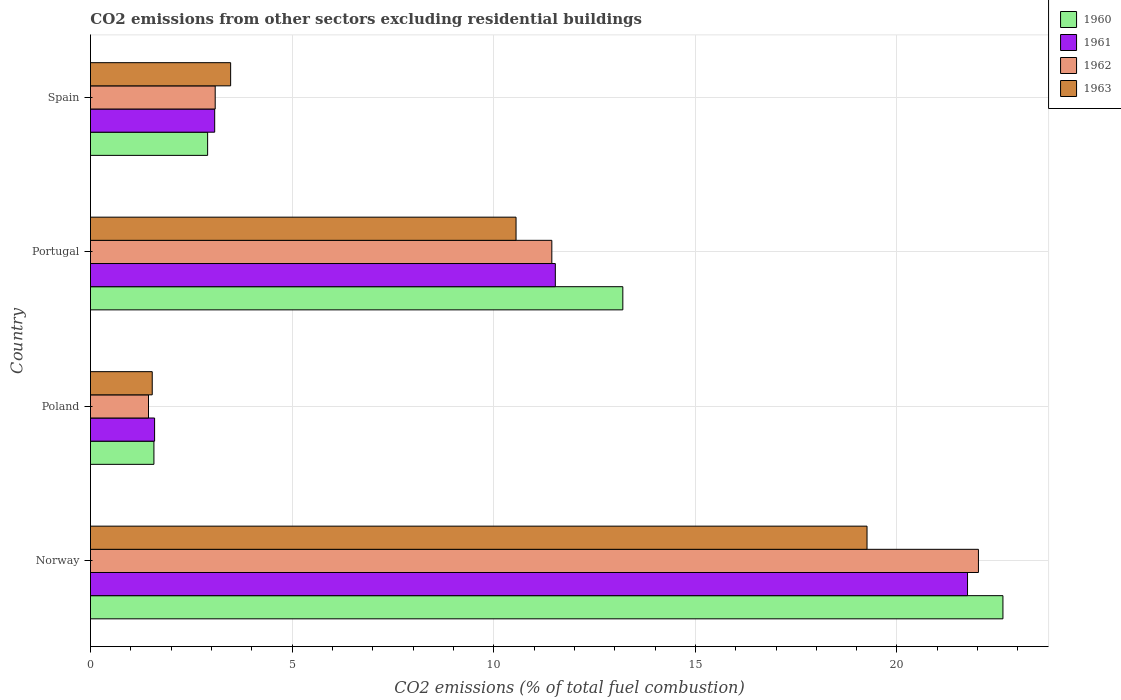Are the number of bars on each tick of the Y-axis equal?
Ensure brevity in your answer.  Yes. How many bars are there on the 4th tick from the bottom?
Ensure brevity in your answer.  4. What is the label of the 1st group of bars from the top?
Ensure brevity in your answer.  Spain. What is the total CO2 emitted in 1963 in Portugal?
Offer a very short reply. 10.55. Across all countries, what is the maximum total CO2 emitted in 1960?
Provide a succinct answer. 22.63. Across all countries, what is the minimum total CO2 emitted in 1962?
Make the answer very short. 1.44. What is the total total CO2 emitted in 1962 in the graph?
Offer a terse response. 37.99. What is the difference between the total CO2 emitted in 1962 in Norway and that in Spain?
Offer a very short reply. 18.93. What is the difference between the total CO2 emitted in 1960 in Poland and the total CO2 emitted in 1963 in Norway?
Keep it short and to the point. -17.68. What is the average total CO2 emitted in 1963 per country?
Offer a very short reply. 8.7. What is the difference between the total CO2 emitted in 1960 and total CO2 emitted in 1962 in Poland?
Offer a very short reply. 0.13. What is the ratio of the total CO2 emitted in 1963 in Norway to that in Portugal?
Your answer should be very brief. 1.82. Is the difference between the total CO2 emitted in 1960 in Norway and Portugal greater than the difference between the total CO2 emitted in 1962 in Norway and Portugal?
Your response must be concise. No. What is the difference between the highest and the second highest total CO2 emitted in 1960?
Keep it short and to the point. 9.43. What is the difference between the highest and the lowest total CO2 emitted in 1960?
Provide a short and direct response. 21.05. Is the sum of the total CO2 emitted in 1960 in Portugal and Spain greater than the maximum total CO2 emitted in 1962 across all countries?
Your response must be concise. No. What does the 4th bar from the top in Portugal represents?
Provide a succinct answer. 1960. Is it the case that in every country, the sum of the total CO2 emitted in 1962 and total CO2 emitted in 1960 is greater than the total CO2 emitted in 1961?
Ensure brevity in your answer.  Yes. What is the difference between two consecutive major ticks on the X-axis?
Your answer should be compact. 5. Are the values on the major ticks of X-axis written in scientific E-notation?
Give a very brief answer. No. Where does the legend appear in the graph?
Provide a short and direct response. Top right. How many legend labels are there?
Make the answer very short. 4. How are the legend labels stacked?
Make the answer very short. Vertical. What is the title of the graph?
Make the answer very short. CO2 emissions from other sectors excluding residential buildings. What is the label or title of the X-axis?
Offer a very short reply. CO2 emissions (% of total fuel combustion). What is the CO2 emissions (% of total fuel combustion) of 1960 in Norway?
Make the answer very short. 22.63. What is the CO2 emissions (% of total fuel combustion) of 1961 in Norway?
Make the answer very short. 21.75. What is the CO2 emissions (% of total fuel combustion) in 1962 in Norway?
Offer a very short reply. 22.02. What is the CO2 emissions (% of total fuel combustion) of 1963 in Norway?
Your answer should be compact. 19.26. What is the CO2 emissions (% of total fuel combustion) of 1960 in Poland?
Make the answer very short. 1.57. What is the CO2 emissions (% of total fuel combustion) in 1961 in Poland?
Your response must be concise. 1.59. What is the CO2 emissions (% of total fuel combustion) of 1962 in Poland?
Your answer should be very brief. 1.44. What is the CO2 emissions (% of total fuel combustion) of 1963 in Poland?
Your answer should be very brief. 1.53. What is the CO2 emissions (% of total fuel combustion) in 1960 in Portugal?
Make the answer very short. 13.2. What is the CO2 emissions (% of total fuel combustion) in 1961 in Portugal?
Your answer should be very brief. 11.53. What is the CO2 emissions (% of total fuel combustion) of 1962 in Portugal?
Ensure brevity in your answer.  11.44. What is the CO2 emissions (% of total fuel combustion) of 1963 in Portugal?
Provide a short and direct response. 10.55. What is the CO2 emissions (% of total fuel combustion) in 1960 in Spain?
Provide a succinct answer. 2.91. What is the CO2 emissions (% of total fuel combustion) of 1961 in Spain?
Your response must be concise. 3.08. What is the CO2 emissions (% of total fuel combustion) in 1962 in Spain?
Keep it short and to the point. 3.09. What is the CO2 emissions (% of total fuel combustion) of 1963 in Spain?
Keep it short and to the point. 3.48. Across all countries, what is the maximum CO2 emissions (% of total fuel combustion) in 1960?
Your answer should be very brief. 22.63. Across all countries, what is the maximum CO2 emissions (% of total fuel combustion) of 1961?
Make the answer very short. 21.75. Across all countries, what is the maximum CO2 emissions (% of total fuel combustion) of 1962?
Your response must be concise. 22.02. Across all countries, what is the maximum CO2 emissions (% of total fuel combustion) of 1963?
Make the answer very short. 19.26. Across all countries, what is the minimum CO2 emissions (% of total fuel combustion) in 1960?
Provide a succinct answer. 1.57. Across all countries, what is the minimum CO2 emissions (% of total fuel combustion) in 1961?
Your response must be concise. 1.59. Across all countries, what is the minimum CO2 emissions (% of total fuel combustion) in 1962?
Your answer should be compact. 1.44. Across all countries, what is the minimum CO2 emissions (% of total fuel combustion) of 1963?
Offer a terse response. 1.53. What is the total CO2 emissions (% of total fuel combustion) of 1960 in the graph?
Your answer should be compact. 40.31. What is the total CO2 emissions (% of total fuel combustion) in 1961 in the graph?
Ensure brevity in your answer.  37.95. What is the total CO2 emissions (% of total fuel combustion) of 1962 in the graph?
Ensure brevity in your answer.  37.99. What is the total CO2 emissions (% of total fuel combustion) in 1963 in the graph?
Offer a very short reply. 34.82. What is the difference between the CO2 emissions (% of total fuel combustion) in 1960 in Norway and that in Poland?
Offer a very short reply. 21.05. What is the difference between the CO2 emissions (% of total fuel combustion) of 1961 in Norway and that in Poland?
Your response must be concise. 20.16. What is the difference between the CO2 emissions (% of total fuel combustion) in 1962 in Norway and that in Poland?
Provide a short and direct response. 20.58. What is the difference between the CO2 emissions (% of total fuel combustion) in 1963 in Norway and that in Poland?
Ensure brevity in your answer.  17.73. What is the difference between the CO2 emissions (% of total fuel combustion) in 1960 in Norway and that in Portugal?
Provide a succinct answer. 9.43. What is the difference between the CO2 emissions (% of total fuel combustion) of 1961 in Norway and that in Portugal?
Provide a succinct answer. 10.22. What is the difference between the CO2 emissions (% of total fuel combustion) of 1962 in Norway and that in Portugal?
Give a very brief answer. 10.58. What is the difference between the CO2 emissions (% of total fuel combustion) of 1963 in Norway and that in Portugal?
Make the answer very short. 8.7. What is the difference between the CO2 emissions (% of total fuel combustion) of 1960 in Norway and that in Spain?
Your answer should be compact. 19.72. What is the difference between the CO2 emissions (% of total fuel combustion) of 1961 in Norway and that in Spain?
Offer a terse response. 18.67. What is the difference between the CO2 emissions (% of total fuel combustion) in 1962 in Norway and that in Spain?
Give a very brief answer. 18.93. What is the difference between the CO2 emissions (% of total fuel combustion) in 1963 in Norway and that in Spain?
Provide a short and direct response. 15.78. What is the difference between the CO2 emissions (% of total fuel combustion) in 1960 in Poland and that in Portugal?
Provide a short and direct response. -11.63. What is the difference between the CO2 emissions (% of total fuel combustion) in 1961 in Poland and that in Portugal?
Offer a terse response. -9.94. What is the difference between the CO2 emissions (% of total fuel combustion) in 1962 in Poland and that in Portugal?
Make the answer very short. -10. What is the difference between the CO2 emissions (% of total fuel combustion) of 1963 in Poland and that in Portugal?
Your response must be concise. -9.02. What is the difference between the CO2 emissions (% of total fuel combustion) of 1960 in Poland and that in Spain?
Provide a succinct answer. -1.33. What is the difference between the CO2 emissions (% of total fuel combustion) in 1961 in Poland and that in Spain?
Give a very brief answer. -1.49. What is the difference between the CO2 emissions (% of total fuel combustion) in 1962 in Poland and that in Spain?
Your answer should be compact. -1.65. What is the difference between the CO2 emissions (% of total fuel combustion) in 1963 in Poland and that in Spain?
Ensure brevity in your answer.  -1.94. What is the difference between the CO2 emissions (% of total fuel combustion) of 1960 in Portugal and that in Spain?
Keep it short and to the point. 10.3. What is the difference between the CO2 emissions (% of total fuel combustion) in 1961 in Portugal and that in Spain?
Make the answer very short. 8.45. What is the difference between the CO2 emissions (% of total fuel combustion) in 1962 in Portugal and that in Spain?
Provide a short and direct response. 8.35. What is the difference between the CO2 emissions (% of total fuel combustion) of 1963 in Portugal and that in Spain?
Your answer should be compact. 7.08. What is the difference between the CO2 emissions (% of total fuel combustion) of 1960 in Norway and the CO2 emissions (% of total fuel combustion) of 1961 in Poland?
Offer a terse response. 21.04. What is the difference between the CO2 emissions (% of total fuel combustion) in 1960 in Norway and the CO2 emissions (% of total fuel combustion) in 1962 in Poland?
Make the answer very short. 21.19. What is the difference between the CO2 emissions (% of total fuel combustion) of 1960 in Norway and the CO2 emissions (% of total fuel combustion) of 1963 in Poland?
Provide a succinct answer. 21.1. What is the difference between the CO2 emissions (% of total fuel combustion) in 1961 in Norway and the CO2 emissions (% of total fuel combustion) in 1962 in Poland?
Offer a very short reply. 20.31. What is the difference between the CO2 emissions (% of total fuel combustion) of 1961 in Norway and the CO2 emissions (% of total fuel combustion) of 1963 in Poland?
Offer a terse response. 20.22. What is the difference between the CO2 emissions (% of total fuel combustion) of 1962 in Norway and the CO2 emissions (% of total fuel combustion) of 1963 in Poland?
Your answer should be very brief. 20.49. What is the difference between the CO2 emissions (% of total fuel combustion) in 1960 in Norway and the CO2 emissions (% of total fuel combustion) in 1961 in Portugal?
Your answer should be compact. 11.1. What is the difference between the CO2 emissions (% of total fuel combustion) in 1960 in Norway and the CO2 emissions (% of total fuel combustion) in 1962 in Portugal?
Provide a short and direct response. 11.19. What is the difference between the CO2 emissions (% of total fuel combustion) of 1960 in Norway and the CO2 emissions (% of total fuel combustion) of 1963 in Portugal?
Keep it short and to the point. 12.07. What is the difference between the CO2 emissions (% of total fuel combustion) in 1961 in Norway and the CO2 emissions (% of total fuel combustion) in 1962 in Portugal?
Give a very brief answer. 10.31. What is the difference between the CO2 emissions (% of total fuel combustion) of 1961 in Norway and the CO2 emissions (% of total fuel combustion) of 1963 in Portugal?
Provide a short and direct response. 11.2. What is the difference between the CO2 emissions (% of total fuel combustion) in 1962 in Norway and the CO2 emissions (% of total fuel combustion) in 1963 in Portugal?
Offer a terse response. 11.47. What is the difference between the CO2 emissions (% of total fuel combustion) in 1960 in Norway and the CO2 emissions (% of total fuel combustion) in 1961 in Spain?
Your answer should be very brief. 19.55. What is the difference between the CO2 emissions (% of total fuel combustion) in 1960 in Norway and the CO2 emissions (% of total fuel combustion) in 1962 in Spain?
Offer a terse response. 19.53. What is the difference between the CO2 emissions (% of total fuel combustion) of 1960 in Norway and the CO2 emissions (% of total fuel combustion) of 1963 in Spain?
Provide a succinct answer. 19.15. What is the difference between the CO2 emissions (% of total fuel combustion) of 1961 in Norway and the CO2 emissions (% of total fuel combustion) of 1962 in Spain?
Make the answer very short. 18.66. What is the difference between the CO2 emissions (% of total fuel combustion) of 1961 in Norway and the CO2 emissions (% of total fuel combustion) of 1963 in Spain?
Keep it short and to the point. 18.27. What is the difference between the CO2 emissions (% of total fuel combustion) of 1962 in Norway and the CO2 emissions (% of total fuel combustion) of 1963 in Spain?
Offer a very short reply. 18.54. What is the difference between the CO2 emissions (% of total fuel combustion) of 1960 in Poland and the CO2 emissions (% of total fuel combustion) of 1961 in Portugal?
Your response must be concise. -9.95. What is the difference between the CO2 emissions (% of total fuel combustion) of 1960 in Poland and the CO2 emissions (% of total fuel combustion) of 1962 in Portugal?
Offer a terse response. -9.87. What is the difference between the CO2 emissions (% of total fuel combustion) of 1960 in Poland and the CO2 emissions (% of total fuel combustion) of 1963 in Portugal?
Make the answer very short. -8.98. What is the difference between the CO2 emissions (% of total fuel combustion) in 1961 in Poland and the CO2 emissions (% of total fuel combustion) in 1962 in Portugal?
Your answer should be compact. -9.85. What is the difference between the CO2 emissions (% of total fuel combustion) in 1961 in Poland and the CO2 emissions (% of total fuel combustion) in 1963 in Portugal?
Offer a terse response. -8.96. What is the difference between the CO2 emissions (% of total fuel combustion) of 1962 in Poland and the CO2 emissions (% of total fuel combustion) of 1963 in Portugal?
Your answer should be compact. -9.11. What is the difference between the CO2 emissions (% of total fuel combustion) in 1960 in Poland and the CO2 emissions (% of total fuel combustion) in 1961 in Spain?
Give a very brief answer. -1.51. What is the difference between the CO2 emissions (% of total fuel combustion) in 1960 in Poland and the CO2 emissions (% of total fuel combustion) in 1962 in Spain?
Provide a succinct answer. -1.52. What is the difference between the CO2 emissions (% of total fuel combustion) in 1960 in Poland and the CO2 emissions (% of total fuel combustion) in 1963 in Spain?
Your answer should be compact. -1.9. What is the difference between the CO2 emissions (% of total fuel combustion) of 1961 in Poland and the CO2 emissions (% of total fuel combustion) of 1962 in Spain?
Offer a very short reply. -1.5. What is the difference between the CO2 emissions (% of total fuel combustion) in 1961 in Poland and the CO2 emissions (% of total fuel combustion) in 1963 in Spain?
Your response must be concise. -1.89. What is the difference between the CO2 emissions (% of total fuel combustion) of 1962 in Poland and the CO2 emissions (% of total fuel combustion) of 1963 in Spain?
Your answer should be compact. -2.04. What is the difference between the CO2 emissions (% of total fuel combustion) of 1960 in Portugal and the CO2 emissions (% of total fuel combustion) of 1961 in Spain?
Provide a succinct answer. 10.12. What is the difference between the CO2 emissions (% of total fuel combustion) in 1960 in Portugal and the CO2 emissions (% of total fuel combustion) in 1962 in Spain?
Keep it short and to the point. 10.11. What is the difference between the CO2 emissions (% of total fuel combustion) of 1960 in Portugal and the CO2 emissions (% of total fuel combustion) of 1963 in Spain?
Provide a succinct answer. 9.73. What is the difference between the CO2 emissions (% of total fuel combustion) of 1961 in Portugal and the CO2 emissions (% of total fuel combustion) of 1962 in Spain?
Ensure brevity in your answer.  8.43. What is the difference between the CO2 emissions (% of total fuel combustion) of 1961 in Portugal and the CO2 emissions (% of total fuel combustion) of 1963 in Spain?
Keep it short and to the point. 8.05. What is the difference between the CO2 emissions (% of total fuel combustion) in 1962 in Portugal and the CO2 emissions (% of total fuel combustion) in 1963 in Spain?
Provide a short and direct response. 7.96. What is the average CO2 emissions (% of total fuel combustion) in 1960 per country?
Give a very brief answer. 10.08. What is the average CO2 emissions (% of total fuel combustion) in 1961 per country?
Provide a succinct answer. 9.49. What is the average CO2 emissions (% of total fuel combustion) in 1962 per country?
Make the answer very short. 9.5. What is the average CO2 emissions (% of total fuel combustion) in 1963 per country?
Provide a short and direct response. 8.7. What is the difference between the CO2 emissions (% of total fuel combustion) in 1960 and CO2 emissions (% of total fuel combustion) in 1961 in Norway?
Your response must be concise. 0.88. What is the difference between the CO2 emissions (% of total fuel combustion) of 1960 and CO2 emissions (% of total fuel combustion) of 1962 in Norway?
Your answer should be very brief. 0.61. What is the difference between the CO2 emissions (% of total fuel combustion) of 1960 and CO2 emissions (% of total fuel combustion) of 1963 in Norway?
Keep it short and to the point. 3.37. What is the difference between the CO2 emissions (% of total fuel combustion) in 1961 and CO2 emissions (% of total fuel combustion) in 1962 in Norway?
Offer a very short reply. -0.27. What is the difference between the CO2 emissions (% of total fuel combustion) of 1961 and CO2 emissions (% of total fuel combustion) of 1963 in Norway?
Give a very brief answer. 2.49. What is the difference between the CO2 emissions (% of total fuel combustion) of 1962 and CO2 emissions (% of total fuel combustion) of 1963 in Norway?
Your response must be concise. 2.76. What is the difference between the CO2 emissions (% of total fuel combustion) in 1960 and CO2 emissions (% of total fuel combustion) in 1961 in Poland?
Your answer should be compact. -0.02. What is the difference between the CO2 emissions (% of total fuel combustion) of 1960 and CO2 emissions (% of total fuel combustion) of 1962 in Poland?
Give a very brief answer. 0.13. What is the difference between the CO2 emissions (% of total fuel combustion) in 1960 and CO2 emissions (% of total fuel combustion) in 1963 in Poland?
Your answer should be compact. 0.04. What is the difference between the CO2 emissions (% of total fuel combustion) of 1961 and CO2 emissions (% of total fuel combustion) of 1962 in Poland?
Make the answer very short. 0.15. What is the difference between the CO2 emissions (% of total fuel combustion) of 1961 and CO2 emissions (% of total fuel combustion) of 1963 in Poland?
Give a very brief answer. 0.06. What is the difference between the CO2 emissions (% of total fuel combustion) in 1962 and CO2 emissions (% of total fuel combustion) in 1963 in Poland?
Provide a short and direct response. -0.09. What is the difference between the CO2 emissions (% of total fuel combustion) in 1960 and CO2 emissions (% of total fuel combustion) in 1961 in Portugal?
Offer a terse response. 1.67. What is the difference between the CO2 emissions (% of total fuel combustion) in 1960 and CO2 emissions (% of total fuel combustion) in 1962 in Portugal?
Provide a short and direct response. 1.76. What is the difference between the CO2 emissions (% of total fuel combustion) in 1960 and CO2 emissions (% of total fuel combustion) in 1963 in Portugal?
Give a very brief answer. 2.65. What is the difference between the CO2 emissions (% of total fuel combustion) in 1961 and CO2 emissions (% of total fuel combustion) in 1962 in Portugal?
Offer a terse response. 0.09. What is the difference between the CO2 emissions (% of total fuel combustion) in 1962 and CO2 emissions (% of total fuel combustion) in 1963 in Portugal?
Provide a short and direct response. 0.89. What is the difference between the CO2 emissions (% of total fuel combustion) of 1960 and CO2 emissions (% of total fuel combustion) of 1961 in Spain?
Give a very brief answer. -0.17. What is the difference between the CO2 emissions (% of total fuel combustion) of 1960 and CO2 emissions (% of total fuel combustion) of 1962 in Spain?
Make the answer very short. -0.19. What is the difference between the CO2 emissions (% of total fuel combustion) of 1960 and CO2 emissions (% of total fuel combustion) of 1963 in Spain?
Your response must be concise. -0.57. What is the difference between the CO2 emissions (% of total fuel combustion) in 1961 and CO2 emissions (% of total fuel combustion) in 1962 in Spain?
Provide a short and direct response. -0.01. What is the difference between the CO2 emissions (% of total fuel combustion) of 1961 and CO2 emissions (% of total fuel combustion) of 1963 in Spain?
Make the answer very short. -0.4. What is the difference between the CO2 emissions (% of total fuel combustion) of 1962 and CO2 emissions (% of total fuel combustion) of 1963 in Spain?
Ensure brevity in your answer.  -0.38. What is the ratio of the CO2 emissions (% of total fuel combustion) in 1960 in Norway to that in Poland?
Provide a short and direct response. 14.38. What is the ratio of the CO2 emissions (% of total fuel combustion) of 1961 in Norway to that in Poland?
Your response must be concise. 13.68. What is the ratio of the CO2 emissions (% of total fuel combustion) in 1962 in Norway to that in Poland?
Your answer should be very brief. 15.3. What is the ratio of the CO2 emissions (% of total fuel combustion) in 1963 in Norway to that in Poland?
Offer a very short reply. 12.57. What is the ratio of the CO2 emissions (% of total fuel combustion) in 1960 in Norway to that in Portugal?
Make the answer very short. 1.71. What is the ratio of the CO2 emissions (% of total fuel combustion) in 1961 in Norway to that in Portugal?
Provide a succinct answer. 1.89. What is the ratio of the CO2 emissions (% of total fuel combustion) in 1962 in Norway to that in Portugal?
Offer a very short reply. 1.92. What is the ratio of the CO2 emissions (% of total fuel combustion) of 1963 in Norway to that in Portugal?
Your answer should be compact. 1.82. What is the ratio of the CO2 emissions (% of total fuel combustion) in 1960 in Norway to that in Spain?
Provide a succinct answer. 7.79. What is the ratio of the CO2 emissions (% of total fuel combustion) in 1961 in Norway to that in Spain?
Offer a very short reply. 7.06. What is the ratio of the CO2 emissions (% of total fuel combustion) in 1962 in Norway to that in Spain?
Your answer should be compact. 7.12. What is the ratio of the CO2 emissions (% of total fuel combustion) of 1963 in Norway to that in Spain?
Your answer should be very brief. 5.54. What is the ratio of the CO2 emissions (% of total fuel combustion) of 1960 in Poland to that in Portugal?
Your answer should be compact. 0.12. What is the ratio of the CO2 emissions (% of total fuel combustion) in 1961 in Poland to that in Portugal?
Your response must be concise. 0.14. What is the ratio of the CO2 emissions (% of total fuel combustion) of 1962 in Poland to that in Portugal?
Ensure brevity in your answer.  0.13. What is the ratio of the CO2 emissions (% of total fuel combustion) in 1963 in Poland to that in Portugal?
Your answer should be compact. 0.15. What is the ratio of the CO2 emissions (% of total fuel combustion) in 1960 in Poland to that in Spain?
Your response must be concise. 0.54. What is the ratio of the CO2 emissions (% of total fuel combustion) of 1961 in Poland to that in Spain?
Your answer should be very brief. 0.52. What is the ratio of the CO2 emissions (% of total fuel combustion) in 1962 in Poland to that in Spain?
Offer a terse response. 0.47. What is the ratio of the CO2 emissions (% of total fuel combustion) of 1963 in Poland to that in Spain?
Your response must be concise. 0.44. What is the ratio of the CO2 emissions (% of total fuel combustion) of 1960 in Portugal to that in Spain?
Your answer should be compact. 4.54. What is the ratio of the CO2 emissions (% of total fuel combustion) of 1961 in Portugal to that in Spain?
Your answer should be compact. 3.74. What is the ratio of the CO2 emissions (% of total fuel combustion) in 1962 in Portugal to that in Spain?
Provide a short and direct response. 3.7. What is the ratio of the CO2 emissions (% of total fuel combustion) of 1963 in Portugal to that in Spain?
Keep it short and to the point. 3.04. What is the difference between the highest and the second highest CO2 emissions (% of total fuel combustion) of 1960?
Offer a terse response. 9.43. What is the difference between the highest and the second highest CO2 emissions (% of total fuel combustion) in 1961?
Your answer should be compact. 10.22. What is the difference between the highest and the second highest CO2 emissions (% of total fuel combustion) of 1962?
Make the answer very short. 10.58. What is the difference between the highest and the second highest CO2 emissions (% of total fuel combustion) of 1963?
Offer a terse response. 8.7. What is the difference between the highest and the lowest CO2 emissions (% of total fuel combustion) in 1960?
Keep it short and to the point. 21.05. What is the difference between the highest and the lowest CO2 emissions (% of total fuel combustion) in 1961?
Your response must be concise. 20.16. What is the difference between the highest and the lowest CO2 emissions (% of total fuel combustion) of 1962?
Make the answer very short. 20.58. What is the difference between the highest and the lowest CO2 emissions (% of total fuel combustion) in 1963?
Offer a very short reply. 17.73. 